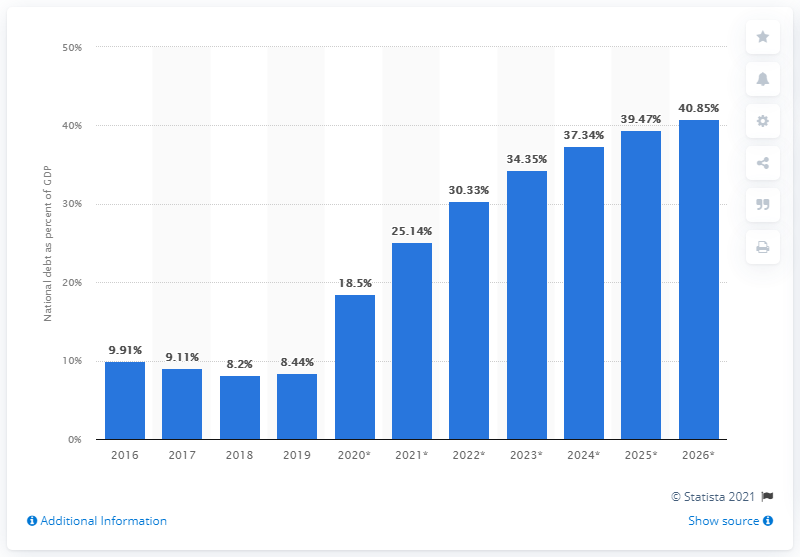Draw attention to some important aspects in this diagram. In 2019, the national debt of Estonia accounted for 8.44% of the country's Gross Domestic Product (GDP), according to the latest available data. 